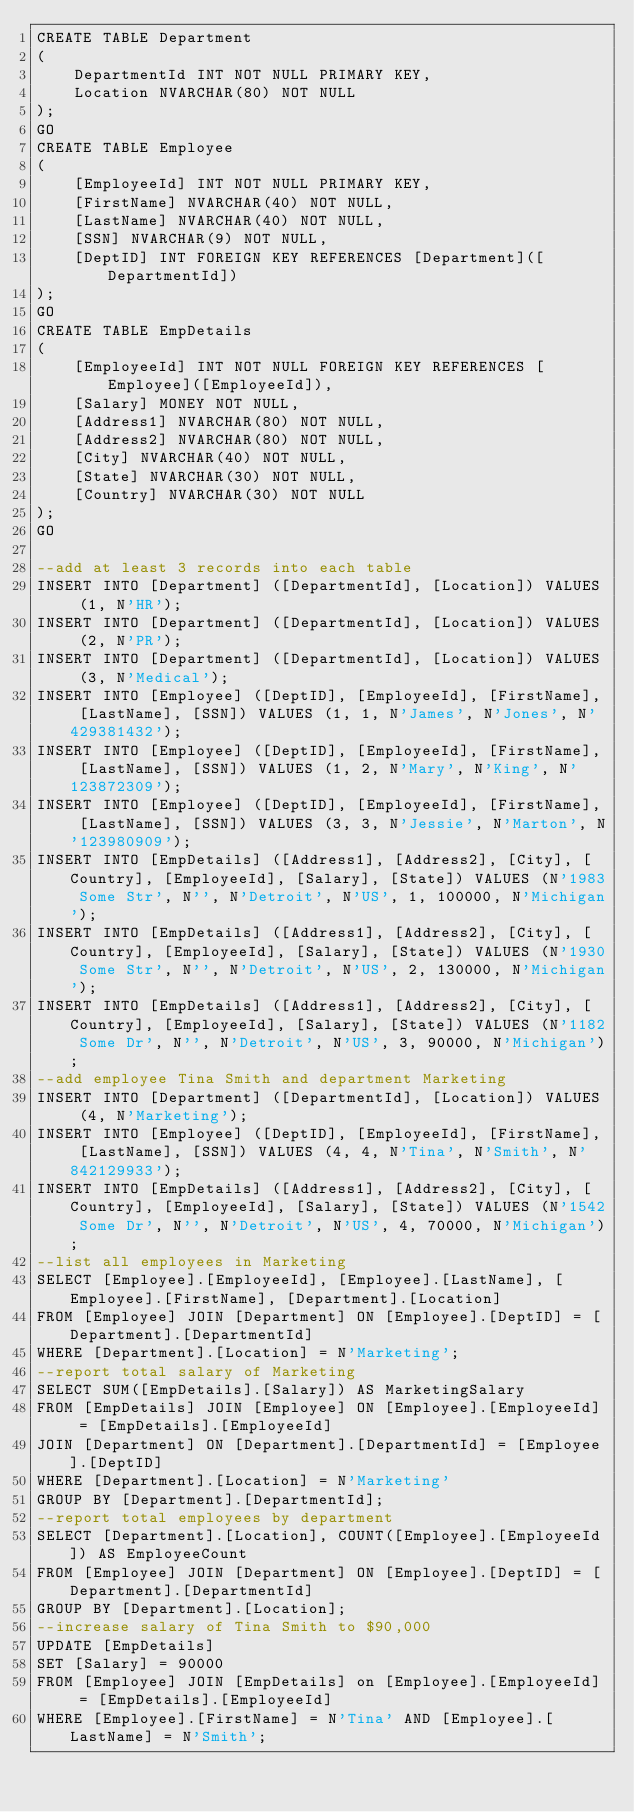Convert code to text. <code><loc_0><loc_0><loc_500><loc_500><_SQL_>CREATE TABLE Department
(
	DepartmentId INT NOT NULL PRIMARY KEY,
	Location NVARCHAR(80) NOT NULL
);
GO
CREATE TABLE Employee
(
	[EmployeeId] INT NOT NULL PRIMARY KEY,
	[FirstName] NVARCHAR(40) NOT NULL,
	[LastName] NVARCHAR(40) NOT NULL,
	[SSN] NVARCHAR(9) NOT NULL,
	[DeptID] INT FOREIGN KEY REFERENCES [Department]([DepartmentId])
);
GO
CREATE TABLE EmpDetails
(
	[EmployeeId] INT NOT NULL FOREIGN KEY REFERENCES [Employee]([EmployeeId]),
	[Salary] MONEY NOT NULL,
	[Address1] NVARCHAR(80) NOT NULL,
	[Address2] NVARCHAR(80) NOT NULL,
	[City] NVARCHAR(40) NOT NULL,
	[State] NVARCHAR(30) NOT NULL,
	[Country] NVARCHAR(30) NOT NULL
);
GO

--add at least 3 records into each table
INSERT INTO [Department] ([DepartmentId], [Location]) VALUES (1, N'HR');
INSERT INTO [Department] ([DepartmentId], [Location]) VALUES (2, N'PR');
INSERT INTO [Department] ([DepartmentId], [Location]) VALUES (3, N'Medical');
INSERT INTO [Employee] ([DeptID], [EmployeeId], [FirstName], [LastName], [SSN]) VALUES (1, 1, N'James', N'Jones', N'429381432');
INSERT INTO [Employee] ([DeptID], [EmployeeId], [FirstName], [LastName], [SSN]) VALUES (1, 2, N'Mary', N'King', N'123872309');
INSERT INTO [Employee] ([DeptID], [EmployeeId], [FirstName], [LastName], [SSN]) VALUES (3, 3, N'Jessie', N'Marton', N'123980909');
INSERT INTO [EmpDetails] ([Address1], [Address2], [City], [Country], [EmployeeId], [Salary], [State]) VALUES (N'1983 Some Str', N'', N'Detroit', N'US', 1, 100000, N'Michigan');
INSERT INTO [EmpDetails] ([Address1], [Address2], [City], [Country], [EmployeeId], [Salary], [State]) VALUES (N'1930 Some Str', N'', N'Detroit', N'US', 2, 130000, N'Michigan');
INSERT INTO [EmpDetails] ([Address1], [Address2], [City], [Country], [EmployeeId], [Salary], [State]) VALUES (N'1182 Some Dr', N'', N'Detroit', N'US', 3, 90000, N'Michigan');
--add employee Tina Smith and department Marketing
INSERT INTO [Department] ([DepartmentId], [Location]) VALUES (4, N'Marketing');
INSERT INTO [Employee] ([DeptID], [EmployeeId], [FirstName], [LastName], [SSN]) VALUES (4, 4, N'Tina', N'Smith', N'842129933');
INSERT INTO [EmpDetails] ([Address1], [Address2], [City], [Country], [EmployeeId], [Salary], [State]) VALUES (N'1542 Some Dr', N'', N'Detroit', N'US', 4, 70000, N'Michigan');
--list all employees in Marketing
SELECT [Employee].[EmployeeId], [Employee].[LastName], [Employee].[FirstName], [Department].[Location]
FROM [Employee] JOIN [Department] ON [Employee].[DeptID] = [Department].[DepartmentId]
WHERE [Department].[Location] = N'Marketing';
--report total salary of Marketing
SELECT SUM([EmpDetails].[Salary]) AS MarketingSalary
FROM [EmpDetails] JOIN [Employee] ON [Employee].[EmployeeId] = [EmpDetails].[EmployeeId]
JOIN [Department] ON [Department].[DepartmentId] = [Employee].[DeptID]
WHERE [Department].[Location] = N'Marketing'
GROUP BY [Department].[DepartmentId];
--report total employees by department
SELECT [Department].[Location], COUNT([Employee].[EmployeeId]) AS EmployeeCount
FROM [Employee] JOIN [Department] ON [Employee].[DeptID] = [Department].[DepartmentId]
GROUP BY [Department].[Location];
--increase salary of Tina Smith to $90,000
UPDATE [EmpDetails]
SET [Salary] = 90000
FROM [Employee] JOIN [EmpDetails] on [Employee].[EmployeeId] = [EmpDetails].[EmployeeId]
WHERE [Employee].[FirstName] = N'Tina' AND [Employee].[LastName] = N'Smith';</code> 